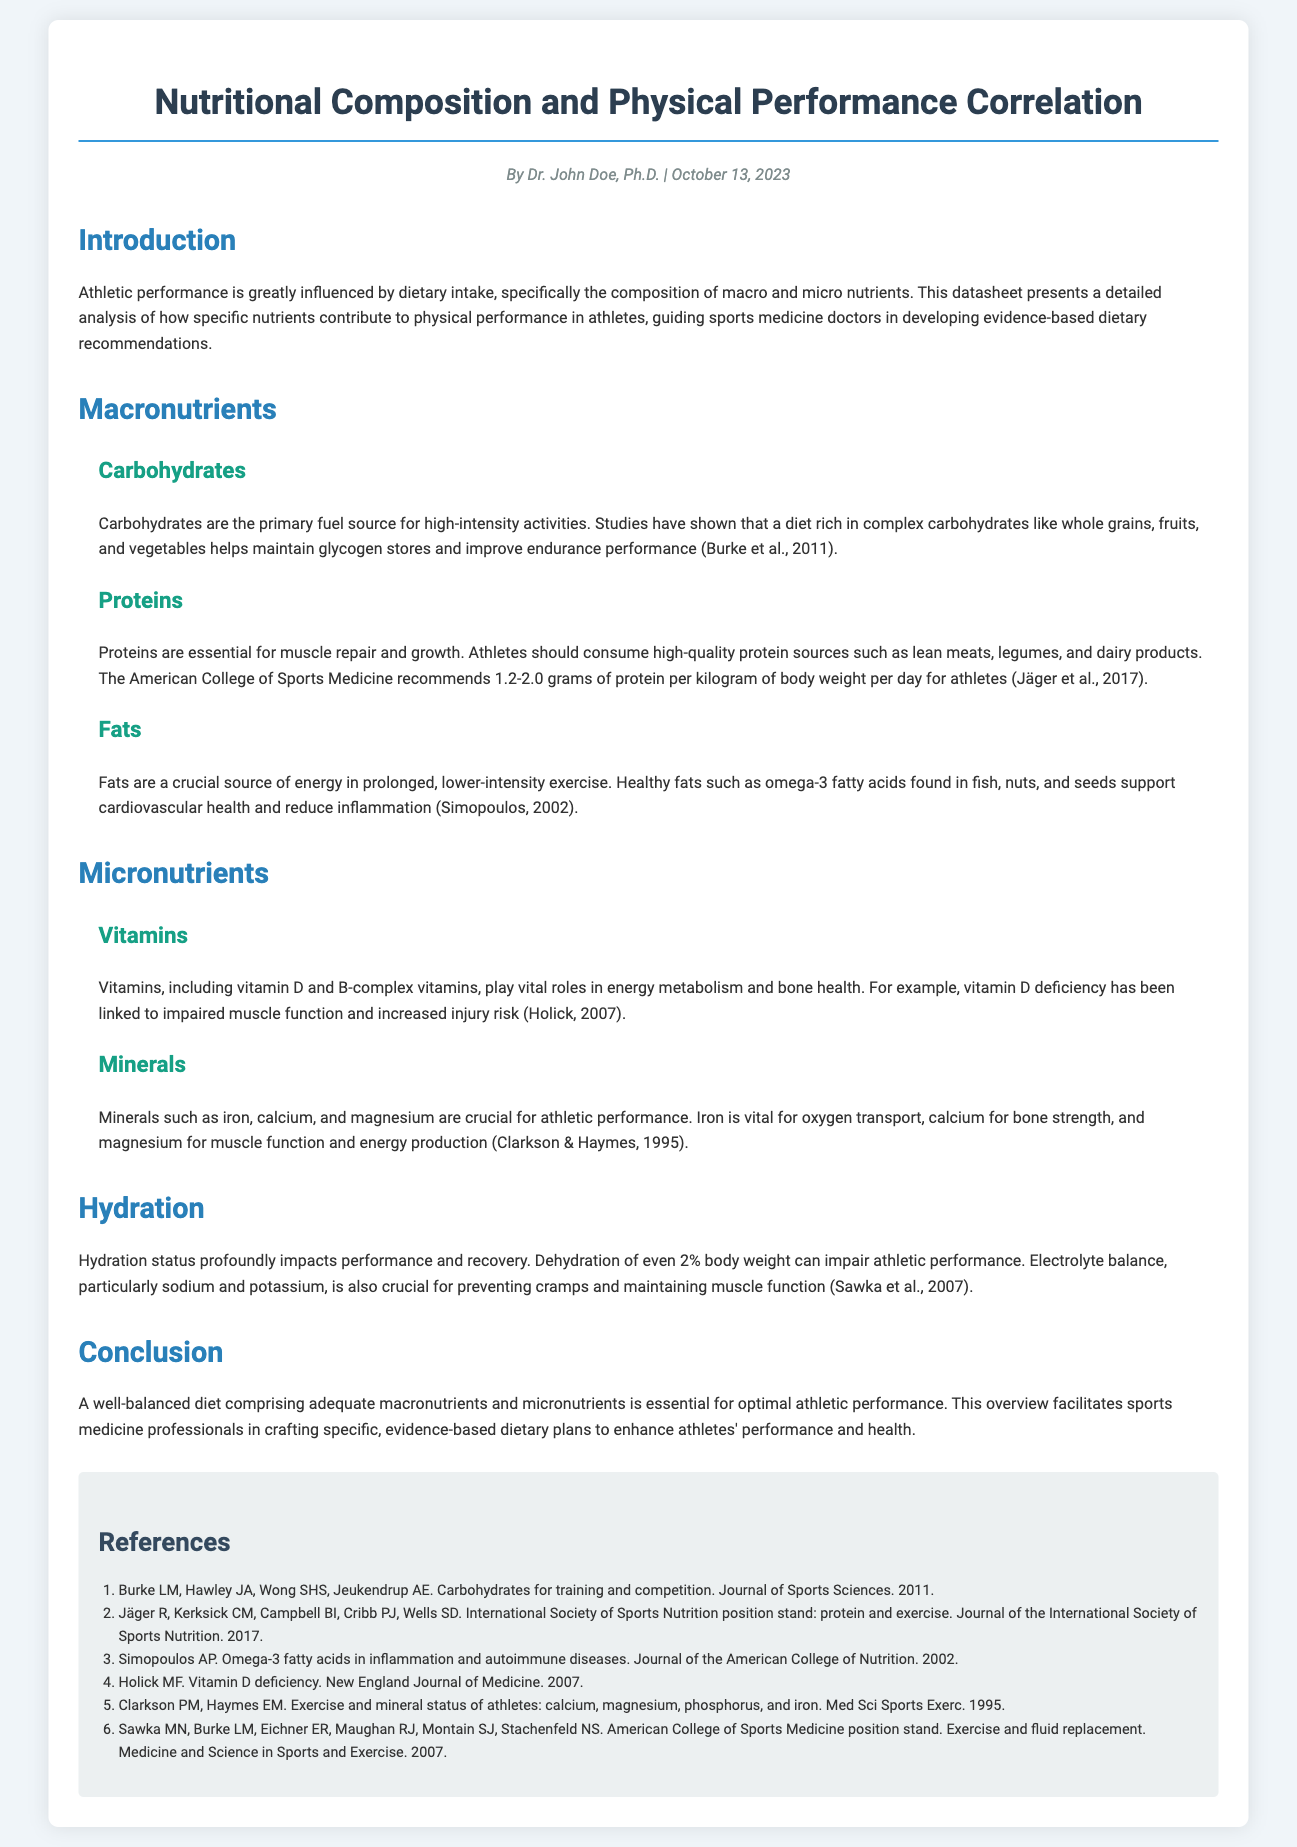What is the title of the document? The title is stated at the top of the document as "Nutritional Composition and Physical Performance Correlation."
Answer: Nutritional Composition and Physical Performance Correlation Who is the author of the document? The author's name is mentioned in the author-date section, indicating who wrote the document.
Answer: Dr. John Doe What is the publication date of the document? The date when the document was published is included in the author-date section.
Answer: October 13, 2023 What is the recommended protein intake for athletes per kilogram of body weight per day? The suggested protein intake is specified in the macros section under proteins.
Answer: 1.2-2.0 grams Which vitamin deficiency is linked to impaired muscle function? The specific vitamin deficiency mentioned in the vitamins subsection that affects muscle function is highlighted.
Answer: Vitamin D What role does iron play in athletic performance? The function of iron in relation to athletic performance is explained in the minerals subsection.
Answer: Oxygen transport What percentage of body weight loss can impair athletic performance? The text discusses dehydration effects in the hydration section, specifically mentioning body weight loss percentage.
Answer: 2% What type of fats are essential for prolonged, lower-intensity exercise? The section on fats describes the kinds of fats that are vital for certain exercise intensities.
Answer: Healthy fats What are the primary sources of carbohydrates for athletes? The sources of carbohydrates for athletes are listed in the carbohydrates subsection.
Answer: Whole grains, fruits, and vegetables 